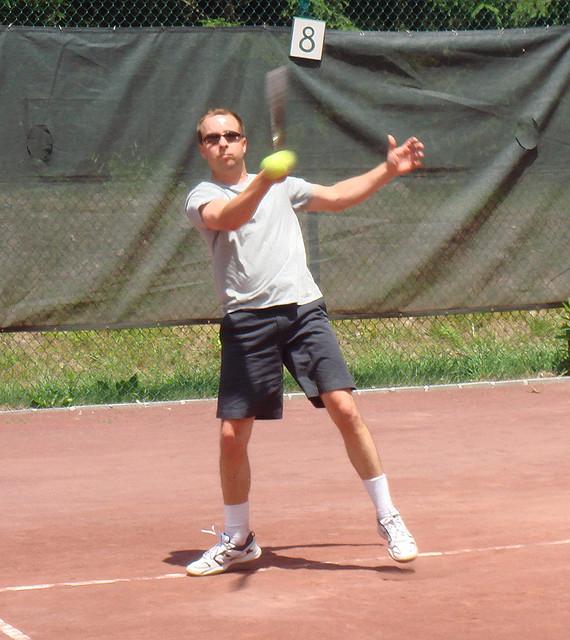Is he wearing glasses?
Write a very short answer. Yes. Why is the white cardboard with the number eight written on it on the fence?
Short answer required. Court number. What surface is the man playing on?
Answer briefly. Clay. 